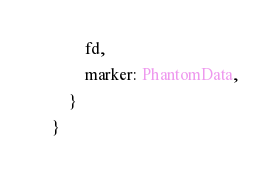Convert code to text. <code><loc_0><loc_0><loc_500><loc_500><_Rust_>            fd,
            marker: PhantomData,
        }
    }
</code> 